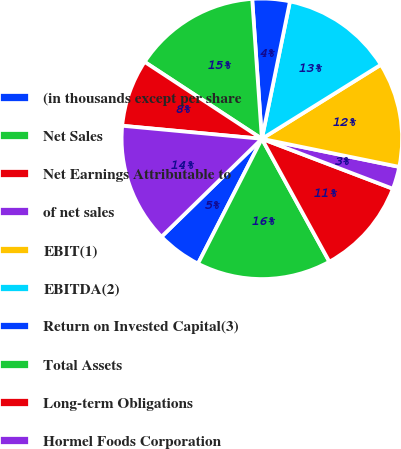Convert chart to OTSL. <chart><loc_0><loc_0><loc_500><loc_500><pie_chart><fcel>(in thousands except per share<fcel>Net Sales<fcel>Net Earnings Attributable to<fcel>of net sales<fcel>EBIT(1)<fcel>EBITDA(2)<fcel>Return on Invested Capital(3)<fcel>Total Assets<fcel>Long-term Obligations<fcel>Hormel Foods Corporation<nl><fcel>5.17%<fcel>15.52%<fcel>11.21%<fcel>2.59%<fcel>12.07%<fcel>12.93%<fcel>4.31%<fcel>14.66%<fcel>7.76%<fcel>13.79%<nl></chart> 